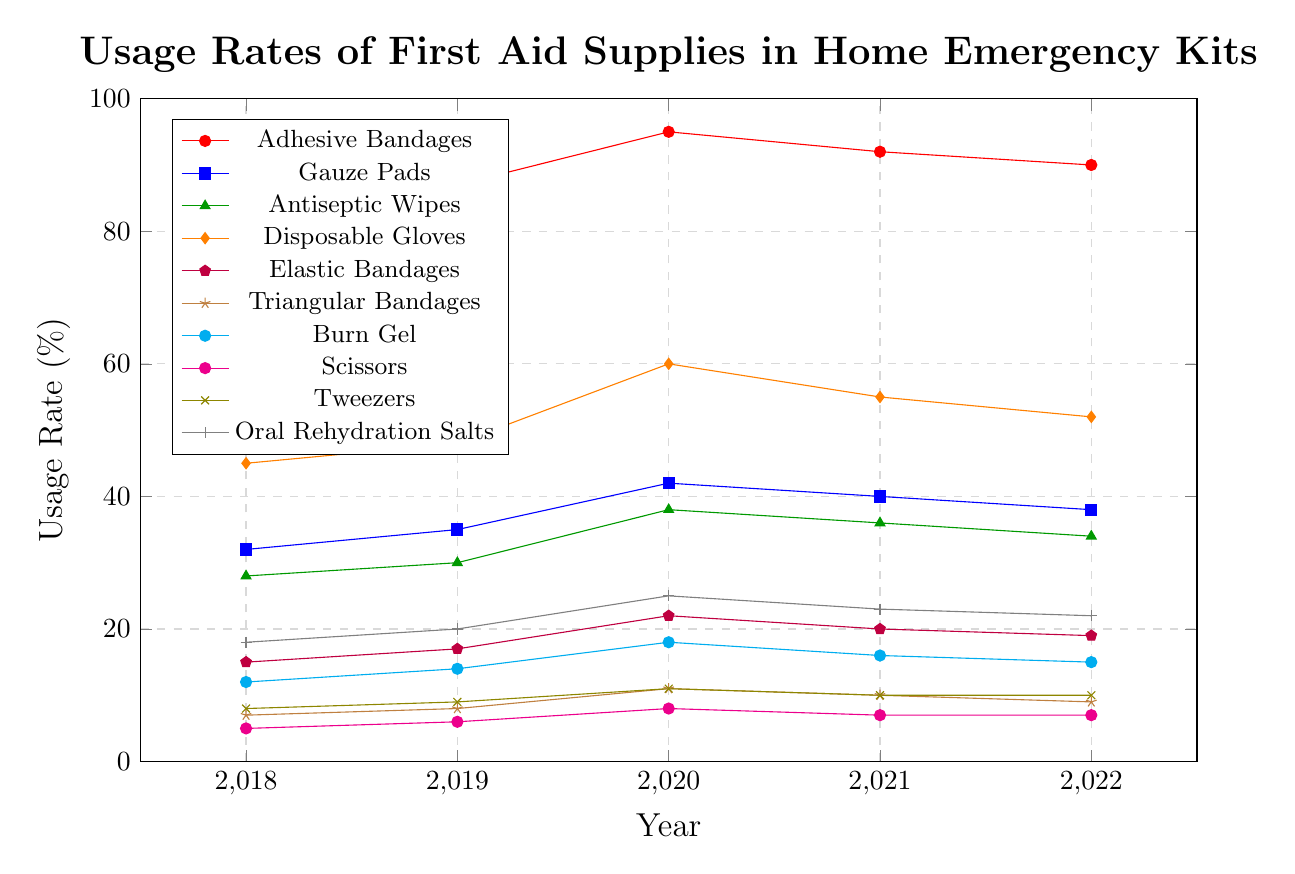Which type of first aid supply had the highest usage rate in 2020? Looking at the figure, the line representing Adhesive Bandages is the highest in 2020.
Answer: Adhesive Bandages How did the usage rate of Disposable Gloves change from 2018 to 2022? In 2018, the usage rate was 45%. In 2022, it was 52%. Subtracting the initial value from the final value, 52 - 45 = 7.
Answer: Increased by 7% Which first aid supply had the smallest increase in usage rate from 2018 to 2022? By comparing the values, Scissors increased from 5% to 7%, a change of 2%, which is the smallest increase.
Answer: Scissors Compare the usage rates of Burn Gel and Tweezers in 2019. Which was higher? The usage rate of Burn Gel in 2019 was 14%, while Tweezers was 9%. So, Burn Gel had a higher usage rate.
Answer: Burn Gel Which type of first aid supply shows a decreasing trend from 2020 to 2022? By examining the lines, Adhesive Bandages, Disposable Gloves, Gauze Pads, Antiseptic Wipes, Triangular Bandages, and Burn Gel show a decreasing trend from 2020 to 2022.
Answer: Adhesive Bandages, Disposable Gloves, Gauze Pads, Antiseptic Wipes, Triangular Bandages, Burn Gel What is the average usage rate of Elastic Bandages from 2018 to 2022? Summing the usage rates for each year: 15 + 17 + 22 + 20 + 19 = 93. Then, dividing by the number of years, 93 / 5 = 18.6.
Answer: 18.6 In which year did Oral Rehydration Salts see the highest usage rate? By identifying the peak of the Oral Rehydration Salts line, we see the highest point is in 2020 at 25%.
Answer: 2020 How do the usage rates of Gauze Pads and Antiseptic Wipes in 2020 compare? The usage rate of Gauze Pads in 2020 is 42%, and Antiseptic Wipes is 38%. Gauze Pads have a higher usage rate.
Answer: Gauze Pads Which first aid supply had the lowest usage rate in 2018? Observing the lowest point on the graph for 2018, Scissors had a usage rate of 5%.
Answer: Scissors What is the trend in usage rates for Triangular Bandages from 2018 to 2022? The usage rates for Triangular Bandages show a slight increase from 7% in 2018 to 8% in 2019 and decrease to 9% in the subsequent years.
Answer: Slight increase followed by a decrease 